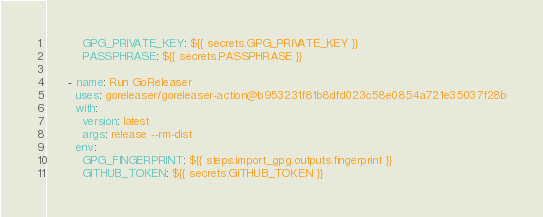Convert code to text. <code><loc_0><loc_0><loc_500><loc_500><_YAML_>          GPG_PRIVATE_KEY: ${{ secrets.GPG_PRIVATE_KEY }}
          PASSPHRASE: ${{ secrets.PASSPHRASE }}

      - name: Run GoReleaser
        uses: goreleaser/goreleaser-action@b953231f81b8dfd023c58e0854a721e35037f28b
        with:
          version: latest
          args: release --rm-dist
        env:
          GPG_FINGERPRINT: ${{ steps.import_gpg.outputs.fingerprint }}
          GITHUB_TOKEN: ${{ secrets.GITHUB_TOKEN }}
</code> 